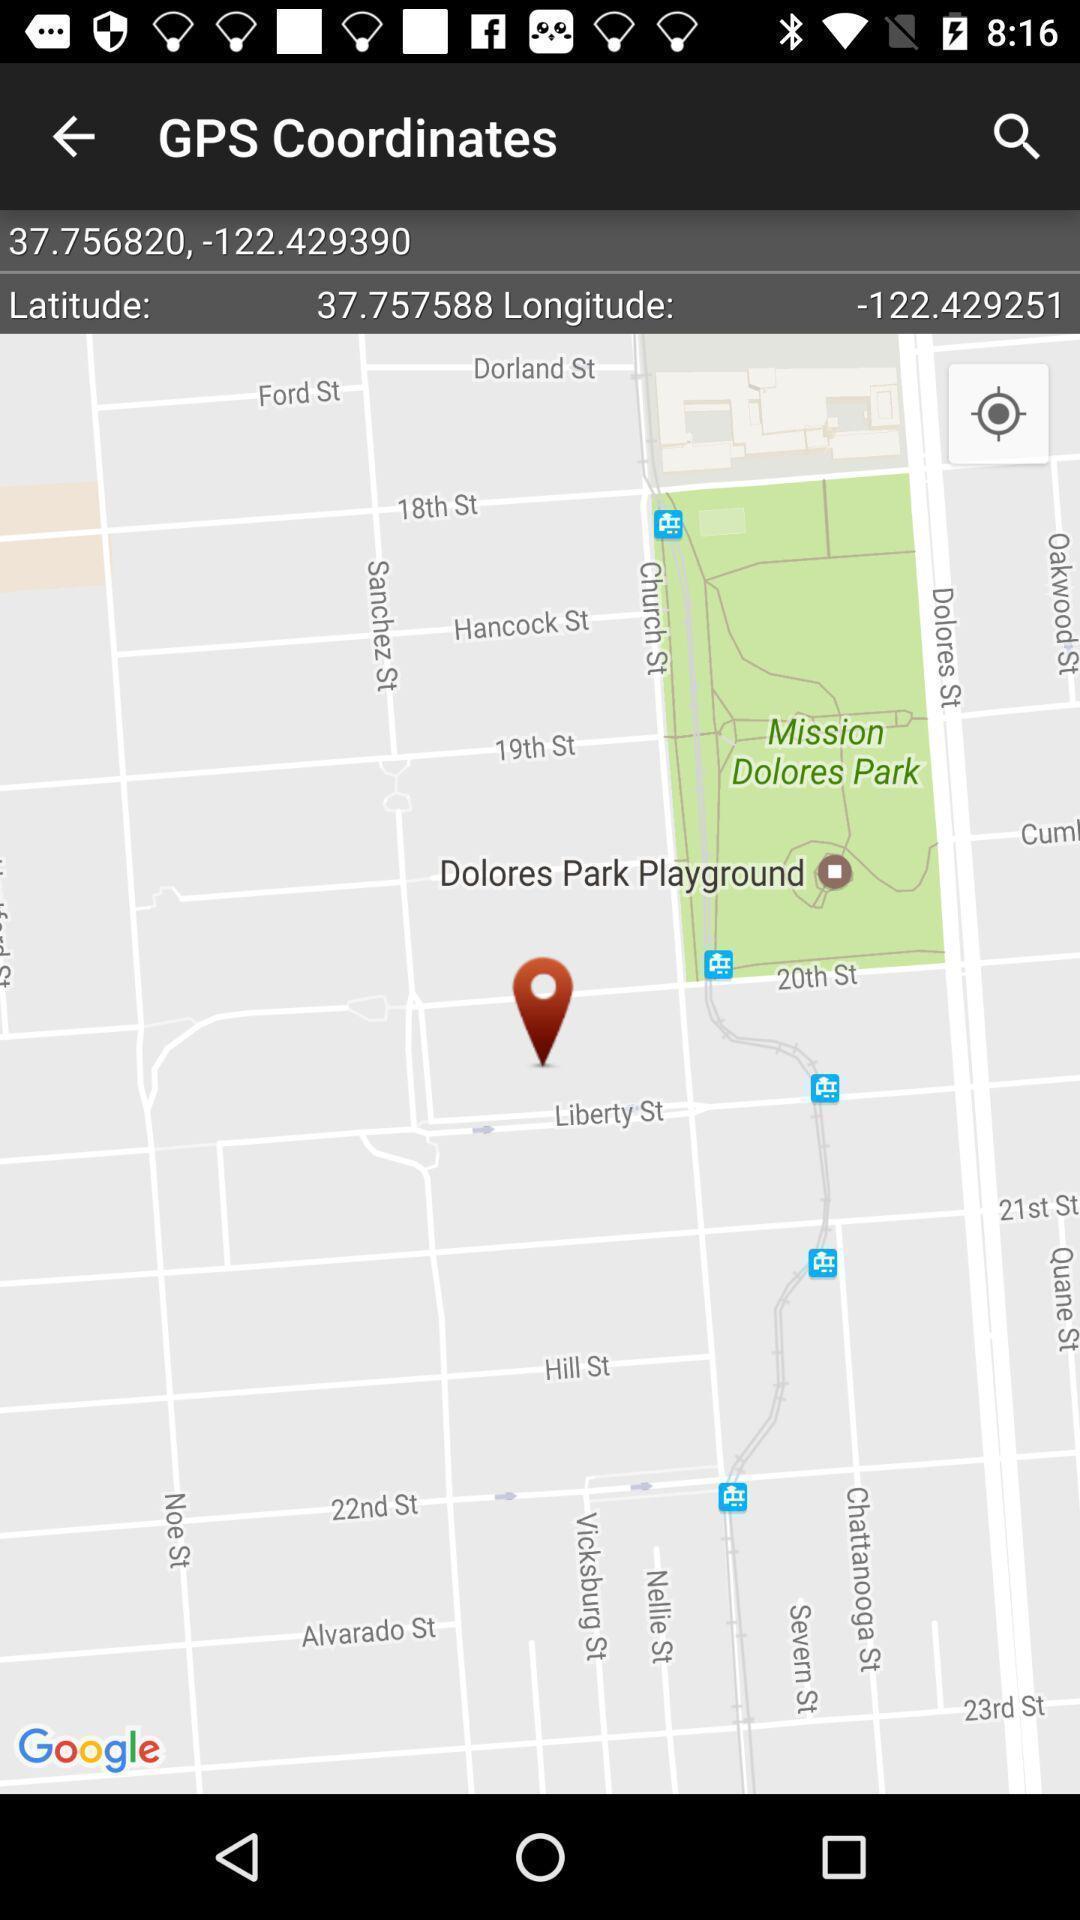Summarize the main components in this picture. Page shows the different locations on mapping app. 